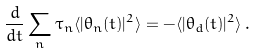Convert formula to latex. <formula><loc_0><loc_0><loc_500><loc_500>\frac { d } { d t } \sum _ { n } \tau _ { n } \langle | \theta _ { n } ( t ) | ^ { 2 } \rangle = - \langle | \theta _ { d } ( t ) | ^ { 2 } \rangle \, .</formula> 